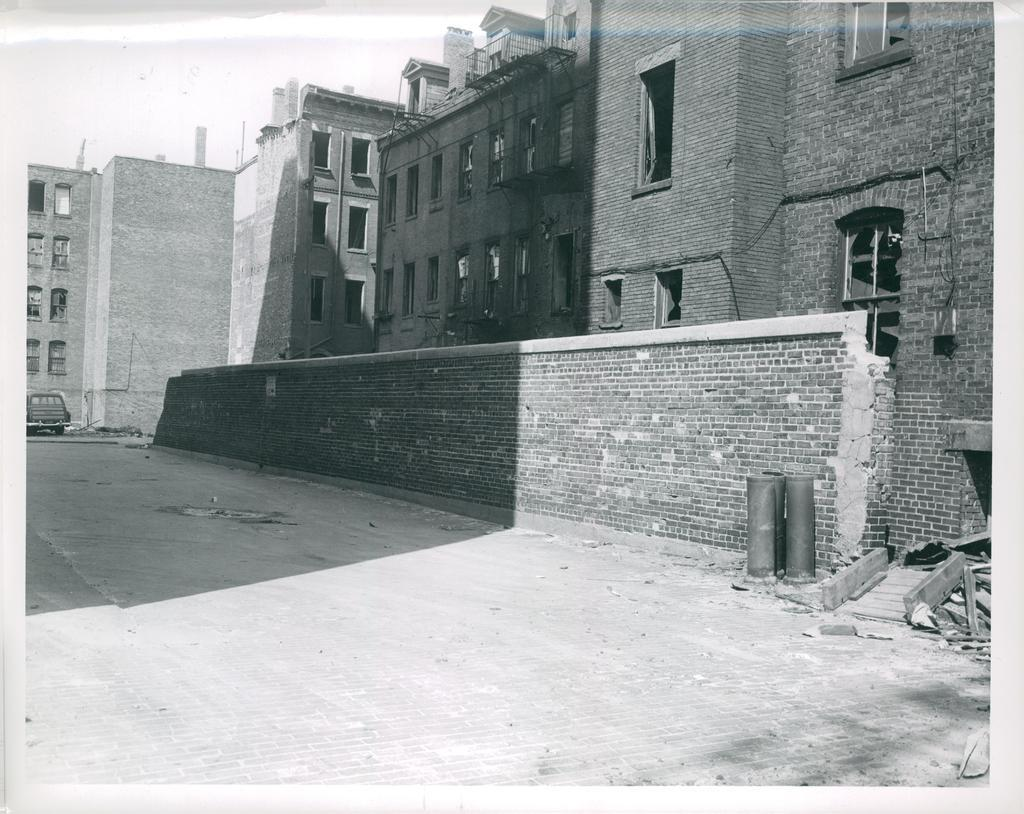What is the main subject of the image? There is a vehicle on the road in the image. What else can be seen in the image besides the vehicle? There is a wall and buildings with windows in the image. What is visible in the background of the image? The sky is visible in the background of the image. What type of brass instrument is being played in the image? There is no brass instrument or any indication of music being played in the image. 